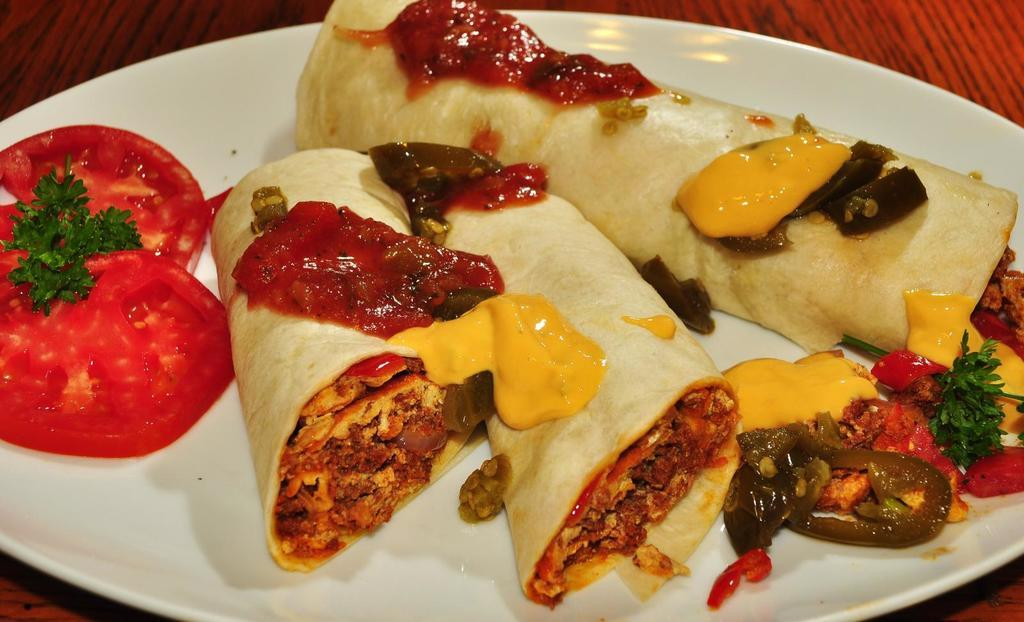What is present on the plate in the image? There is food on the plate in the image. What type of surface is visible at the bottom of the image? There is a wooden surface at the bottom of the image. What type of disease can be seen affecting the food on the plate? There is no disease present in the image, and the food on the plate appears normal. How is the food on the plate being distributed? The distribution of the food on the plate is not mentioned in the facts, but it appears to be evenly spread across the plate. 